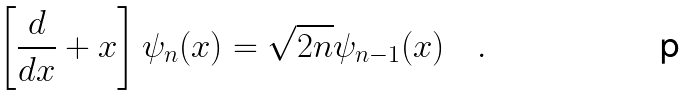Convert formula to latex. <formula><loc_0><loc_0><loc_500><loc_500>\left [ \frac { d } { d x } + x \right ] \psi _ { n } ( x ) = \sqrt { 2 n } \psi _ { n - 1 } ( x ) \quad .</formula> 